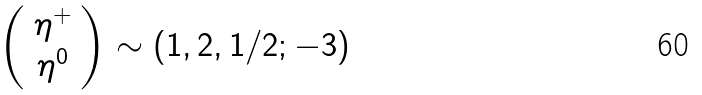<formula> <loc_0><loc_0><loc_500><loc_500>\left ( \begin{array} { c } \eta ^ { + } \\ \eta ^ { 0 } \end{array} \right ) \sim ( 1 , 2 , 1 / 2 ; - 3 )</formula> 